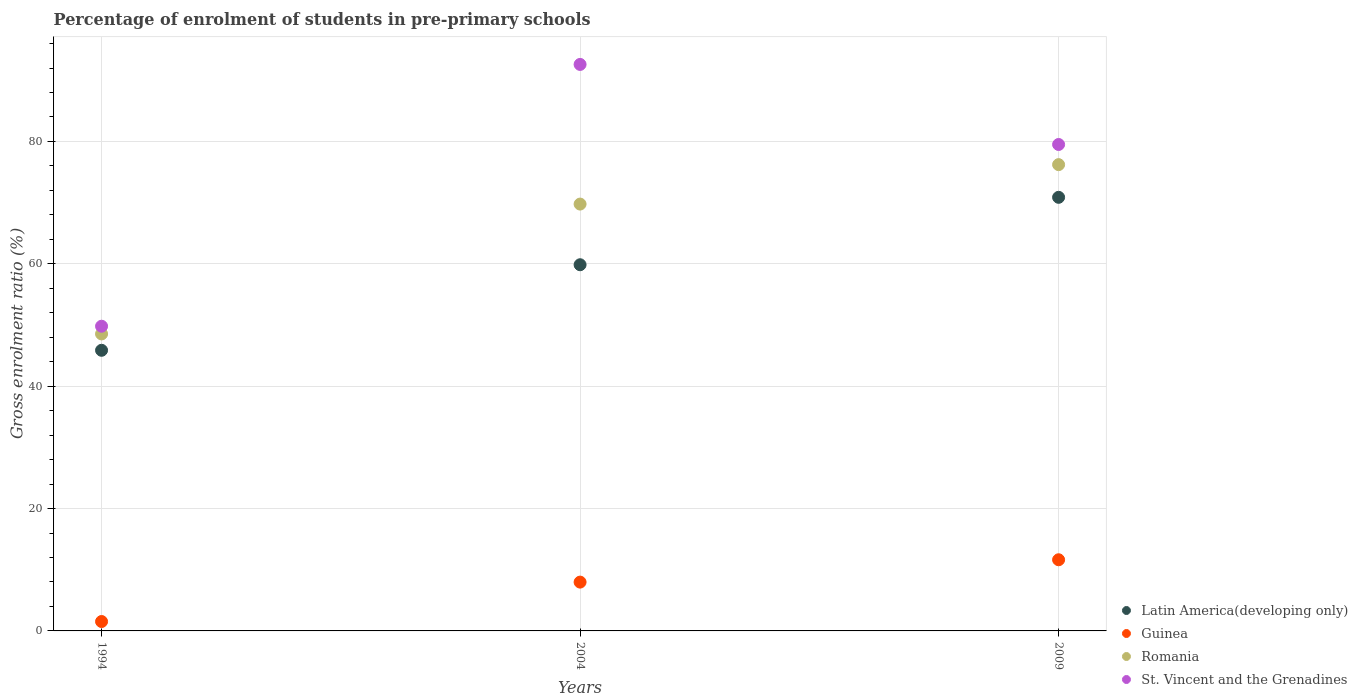How many different coloured dotlines are there?
Your response must be concise. 4. What is the percentage of students enrolled in pre-primary schools in Latin America(developing only) in 2009?
Provide a short and direct response. 70.87. Across all years, what is the maximum percentage of students enrolled in pre-primary schools in Guinea?
Provide a short and direct response. 11.63. Across all years, what is the minimum percentage of students enrolled in pre-primary schools in Latin America(developing only)?
Your answer should be compact. 45.87. In which year was the percentage of students enrolled in pre-primary schools in Guinea maximum?
Make the answer very short. 2009. What is the total percentage of students enrolled in pre-primary schools in Guinea in the graph?
Your answer should be very brief. 21.14. What is the difference between the percentage of students enrolled in pre-primary schools in Latin America(developing only) in 1994 and that in 2009?
Make the answer very short. -25. What is the difference between the percentage of students enrolled in pre-primary schools in Latin America(developing only) in 2004 and the percentage of students enrolled in pre-primary schools in St. Vincent and the Grenadines in 2009?
Offer a terse response. -19.65. What is the average percentage of students enrolled in pre-primary schools in St. Vincent and the Grenadines per year?
Give a very brief answer. 73.97. In the year 2009, what is the difference between the percentage of students enrolled in pre-primary schools in Latin America(developing only) and percentage of students enrolled in pre-primary schools in St. Vincent and the Grenadines?
Offer a terse response. -8.64. In how many years, is the percentage of students enrolled in pre-primary schools in St. Vincent and the Grenadines greater than 52 %?
Ensure brevity in your answer.  2. What is the ratio of the percentage of students enrolled in pre-primary schools in Guinea in 1994 to that in 2009?
Your answer should be very brief. 0.13. Is the difference between the percentage of students enrolled in pre-primary schools in Latin America(developing only) in 2004 and 2009 greater than the difference between the percentage of students enrolled in pre-primary schools in St. Vincent and the Grenadines in 2004 and 2009?
Provide a short and direct response. No. What is the difference between the highest and the second highest percentage of students enrolled in pre-primary schools in Romania?
Offer a very short reply. 6.45. What is the difference between the highest and the lowest percentage of students enrolled in pre-primary schools in Latin America(developing only)?
Your answer should be very brief. 25. In how many years, is the percentage of students enrolled in pre-primary schools in St. Vincent and the Grenadines greater than the average percentage of students enrolled in pre-primary schools in St. Vincent and the Grenadines taken over all years?
Ensure brevity in your answer.  2. Is it the case that in every year, the sum of the percentage of students enrolled in pre-primary schools in Romania and percentage of students enrolled in pre-primary schools in Guinea  is greater than the percentage of students enrolled in pre-primary schools in Latin America(developing only)?
Make the answer very short. Yes. Is the percentage of students enrolled in pre-primary schools in Guinea strictly less than the percentage of students enrolled in pre-primary schools in St. Vincent and the Grenadines over the years?
Ensure brevity in your answer.  Yes. Are the values on the major ticks of Y-axis written in scientific E-notation?
Offer a very short reply. No. Does the graph contain grids?
Make the answer very short. Yes. Where does the legend appear in the graph?
Your response must be concise. Bottom right. How many legend labels are there?
Your response must be concise. 4. What is the title of the graph?
Offer a very short reply. Percentage of enrolment of students in pre-primary schools. Does "Cabo Verde" appear as one of the legend labels in the graph?
Offer a terse response. No. What is the label or title of the Y-axis?
Your answer should be very brief. Gross enrolment ratio (%). What is the Gross enrolment ratio (%) in Latin America(developing only) in 1994?
Ensure brevity in your answer.  45.87. What is the Gross enrolment ratio (%) in Guinea in 1994?
Give a very brief answer. 1.54. What is the Gross enrolment ratio (%) in Romania in 1994?
Your answer should be very brief. 48.54. What is the Gross enrolment ratio (%) in St. Vincent and the Grenadines in 1994?
Your answer should be very brief. 49.8. What is the Gross enrolment ratio (%) of Latin America(developing only) in 2004?
Provide a short and direct response. 59.85. What is the Gross enrolment ratio (%) of Guinea in 2004?
Your response must be concise. 7.98. What is the Gross enrolment ratio (%) in Romania in 2004?
Ensure brevity in your answer.  69.77. What is the Gross enrolment ratio (%) in St. Vincent and the Grenadines in 2004?
Give a very brief answer. 92.59. What is the Gross enrolment ratio (%) in Latin America(developing only) in 2009?
Make the answer very short. 70.87. What is the Gross enrolment ratio (%) of Guinea in 2009?
Provide a short and direct response. 11.63. What is the Gross enrolment ratio (%) of Romania in 2009?
Offer a very short reply. 76.21. What is the Gross enrolment ratio (%) of St. Vincent and the Grenadines in 2009?
Your answer should be very brief. 79.51. Across all years, what is the maximum Gross enrolment ratio (%) of Latin America(developing only)?
Offer a terse response. 70.87. Across all years, what is the maximum Gross enrolment ratio (%) in Guinea?
Provide a succinct answer. 11.63. Across all years, what is the maximum Gross enrolment ratio (%) in Romania?
Offer a very short reply. 76.21. Across all years, what is the maximum Gross enrolment ratio (%) in St. Vincent and the Grenadines?
Keep it short and to the point. 92.59. Across all years, what is the minimum Gross enrolment ratio (%) of Latin America(developing only)?
Offer a terse response. 45.87. Across all years, what is the minimum Gross enrolment ratio (%) in Guinea?
Provide a succinct answer. 1.54. Across all years, what is the minimum Gross enrolment ratio (%) in Romania?
Give a very brief answer. 48.54. Across all years, what is the minimum Gross enrolment ratio (%) of St. Vincent and the Grenadines?
Offer a terse response. 49.8. What is the total Gross enrolment ratio (%) in Latin America(developing only) in the graph?
Make the answer very short. 176.59. What is the total Gross enrolment ratio (%) in Guinea in the graph?
Provide a succinct answer. 21.14. What is the total Gross enrolment ratio (%) in Romania in the graph?
Your response must be concise. 194.52. What is the total Gross enrolment ratio (%) of St. Vincent and the Grenadines in the graph?
Provide a succinct answer. 221.9. What is the difference between the Gross enrolment ratio (%) of Latin America(developing only) in 1994 and that in 2004?
Your answer should be compact. -13.98. What is the difference between the Gross enrolment ratio (%) of Guinea in 1994 and that in 2004?
Provide a succinct answer. -6.44. What is the difference between the Gross enrolment ratio (%) in Romania in 1994 and that in 2004?
Ensure brevity in your answer.  -21.22. What is the difference between the Gross enrolment ratio (%) in St. Vincent and the Grenadines in 1994 and that in 2004?
Your answer should be compact. -42.79. What is the difference between the Gross enrolment ratio (%) of Latin America(developing only) in 1994 and that in 2009?
Give a very brief answer. -25. What is the difference between the Gross enrolment ratio (%) of Guinea in 1994 and that in 2009?
Offer a terse response. -10.09. What is the difference between the Gross enrolment ratio (%) in Romania in 1994 and that in 2009?
Your answer should be very brief. -27.67. What is the difference between the Gross enrolment ratio (%) in St. Vincent and the Grenadines in 1994 and that in 2009?
Your answer should be compact. -29.7. What is the difference between the Gross enrolment ratio (%) in Latin America(developing only) in 2004 and that in 2009?
Provide a succinct answer. -11.02. What is the difference between the Gross enrolment ratio (%) in Guinea in 2004 and that in 2009?
Your answer should be compact. -3.65. What is the difference between the Gross enrolment ratio (%) in Romania in 2004 and that in 2009?
Provide a succinct answer. -6.45. What is the difference between the Gross enrolment ratio (%) of St. Vincent and the Grenadines in 2004 and that in 2009?
Your response must be concise. 13.08. What is the difference between the Gross enrolment ratio (%) of Latin America(developing only) in 1994 and the Gross enrolment ratio (%) of Guinea in 2004?
Offer a very short reply. 37.89. What is the difference between the Gross enrolment ratio (%) in Latin America(developing only) in 1994 and the Gross enrolment ratio (%) in Romania in 2004?
Offer a very short reply. -23.9. What is the difference between the Gross enrolment ratio (%) in Latin America(developing only) in 1994 and the Gross enrolment ratio (%) in St. Vincent and the Grenadines in 2004?
Your answer should be compact. -46.72. What is the difference between the Gross enrolment ratio (%) in Guinea in 1994 and the Gross enrolment ratio (%) in Romania in 2004?
Give a very brief answer. -68.23. What is the difference between the Gross enrolment ratio (%) in Guinea in 1994 and the Gross enrolment ratio (%) in St. Vincent and the Grenadines in 2004?
Provide a succinct answer. -91.05. What is the difference between the Gross enrolment ratio (%) of Romania in 1994 and the Gross enrolment ratio (%) of St. Vincent and the Grenadines in 2004?
Provide a short and direct response. -44.05. What is the difference between the Gross enrolment ratio (%) in Latin America(developing only) in 1994 and the Gross enrolment ratio (%) in Guinea in 2009?
Provide a short and direct response. 34.24. What is the difference between the Gross enrolment ratio (%) in Latin America(developing only) in 1994 and the Gross enrolment ratio (%) in Romania in 2009?
Your answer should be compact. -30.35. What is the difference between the Gross enrolment ratio (%) in Latin America(developing only) in 1994 and the Gross enrolment ratio (%) in St. Vincent and the Grenadines in 2009?
Provide a short and direct response. -33.64. What is the difference between the Gross enrolment ratio (%) in Guinea in 1994 and the Gross enrolment ratio (%) in Romania in 2009?
Provide a succinct answer. -74.68. What is the difference between the Gross enrolment ratio (%) in Guinea in 1994 and the Gross enrolment ratio (%) in St. Vincent and the Grenadines in 2009?
Give a very brief answer. -77.97. What is the difference between the Gross enrolment ratio (%) of Romania in 1994 and the Gross enrolment ratio (%) of St. Vincent and the Grenadines in 2009?
Ensure brevity in your answer.  -30.96. What is the difference between the Gross enrolment ratio (%) of Latin America(developing only) in 2004 and the Gross enrolment ratio (%) of Guinea in 2009?
Make the answer very short. 48.22. What is the difference between the Gross enrolment ratio (%) of Latin America(developing only) in 2004 and the Gross enrolment ratio (%) of Romania in 2009?
Your answer should be very brief. -16.36. What is the difference between the Gross enrolment ratio (%) in Latin America(developing only) in 2004 and the Gross enrolment ratio (%) in St. Vincent and the Grenadines in 2009?
Make the answer very short. -19.65. What is the difference between the Gross enrolment ratio (%) of Guinea in 2004 and the Gross enrolment ratio (%) of Romania in 2009?
Offer a terse response. -68.23. What is the difference between the Gross enrolment ratio (%) of Guinea in 2004 and the Gross enrolment ratio (%) of St. Vincent and the Grenadines in 2009?
Offer a terse response. -71.53. What is the difference between the Gross enrolment ratio (%) of Romania in 2004 and the Gross enrolment ratio (%) of St. Vincent and the Grenadines in 2009?
Ensure brevity in your answer.  -9.74. What is the average Gross enrolment ratio (%) in Latin America(developing only) per year?
Provide a short and direct response. 58.86. What is the average Gross enrolment ratio (%) in Guinea per year?
Offer a very short reply. 7.05. What is the average Gross enrolment ratio (%) of Romania per year?
Keep it short and to the point. 64.84. What is the average Gross enrolment ratio (%) in St. Vincent and the Grenadines per year?
Your response must be concise. 73.97. In the year 1994, what is the difference between the Gross enrolment ratio (%) in Latin America(developing only) and Gross enrolment ratio (%) in Guinea?
Ensure brevity in your answer.  44.33. In the year 1994, what is the difference between the Gross enrolment ratio (%) in Latin America(developing only) and Gross enrolment ratio (%) in Romania?
Ensure brevity in your answer.  -2.67. In the year 1994, what is the difference between the Gross enrolment ratio (%) in Latin America(developing only) and Gross enrolment ratio (%) in St. Vincent and the Grenadines?
Your answer should be compact. -3.93. In the year 1994, what is the difference between the Gross enrolment ratio (%) of Guinea and Gross enrolment ratio (%) of Romania?
Offer a very short reply. -47.01. In the year 1994, what is the difference between the Gross enrolment ratio (%) of Guinea and Gross enrolment ratio (%) of St. Vincent and the Grenadines?
Keep it short and to the point. -48.27. In the year 1994, what is the difference between the Gross enrolment ratio (%) in Romania and Gross enrolment ratio (%) in St. Vincent and the Grenadines?
Your answer should be very brief. -1.26. In the year 2004, what is the difference between the Gross enrolment ratio (%) of Latin America(developing only) and Gross enrolment ratio (%) of Guinea?
Your answer should be very brief. 51.87. In the year 2004, what is the difference between the Gross enrolment ratio (%) in Latin America(developing only) and Gross enrolment ratio (%) in Romania?
Your answer should be compact. -9.91. In the year 2004, what is the difference between the Gross enrolment ratio (%) in Latin America(developing only) and Gross enrolment ratio (%) in St. Vincent and the Grenadines?
Provide a succinct answer. -32.74. In the year 2004, what is the difference between the Gross enrolment ratio (%) in Guinea and Gross enrolment ratio (%) in Romania?
Ensure brevity in your answer.  -61.79. In the year 2004, what is the difference between the Gross enrolment ratio (%) in Guinea and Gross enrolment ratio (%) in St. Vincent and the Grenadines?
Offer a very short reply. -84.61. In the year 2004, what is the difference between the Gross enrolment ratio (%) in Romania and Gross enrolment ratio (%) in St. Vincent and the Grenadines?
Offer a very short reply. -22.82. In the year 2009, what is the difference between the Gross enrolment ratio (%) in Latin America(developing only) and Gross enrolment ratio (%) in Guinea?
Your answer should be compact. 59.24. In the year 2009, what is the difference between the Gross enrolment ratio (%) in Latin America(developing only) and Gross enrolment ratio (%) in Romania?
Your answer should be compact. -5.34. In the year 2009, what is the difference between the Gross enrolment ratio (%) in Latin America(developing only) and Gross enrolment ratio (%) in St. Vincent and the Grenadines?
Keep it short and to the point. -8.64. In the year 2009, what is the difference between the Gross enrolment ratio (%) in Guinea and Gross enrolment ratio (%) in Romania?
Offer a very short reply. -64.58. In the year 2009, what is the difference between the Gross enrolment ratio (%) in Guinea and Gross enrolment ratio (%) in St. Vincent and the Grenadines?
Make the answer very short. -67.87. In the year 2009, what is the difference between the Gross enrolment ratio (%) of Romania and Gross enrolment ratio (%) of St. Vincent and the Grenadines?
Ensure brevity in your answer.  -3.29. What is the ratio of the Gross enrolment ratio (%) in Latin America(developing only) in 1994 to that in 2004?
Offer a terse response. 0.77. What is the ratio of the Gross enrolment ratio (%) in Guinea in 1994 to that in 2004?
Give a very brief answer. 0.19. What is the ratio of the Gross enrolment ratio (%) in Romania in 1994 to that in 2004?
Your answer should be compact. 0.7. What is the ratio of the Gross enrolment ratio (%) of St. Vincent and the Grenadines in 1994 to that in 2004?
Keep it short and to the point. 0.54. What is the ratio of the Gross enrolment ratio (%) in Latin America(developing only) in 1994 to that in 2009?
Provide a succinct answer. 0.65. What is the ratio of the Gross enrolment ratio (%) of Guinea in 1994 to that in 2009?
Offer a terse response. 0.13. What is the ratio of the Gross enrolment ratio (%) of Romania in 1994 to that in 2009?
Offer a terse response. 0.64. What is the ratio of the Gross enrolment ratio (%) of St. Vincent and the Grenadines in 1994 to that in 2009?
Ensure brevity in your answer.  0.63. What is the ratio of the Gross enrolment ratio (%) in Latin America(developing only) in 2004 to that in 2009?
Ensure brevity in your answer.  0.84. What is the ratio of the Gross enrolment ratio (%) of Guinea in 2004 to that in 2009?
Your response must be concise. 0.69. What is the ratio of the Gross enrolment ratio (%) in Romania in 2004 to that in 2009?
Give a very brief answer. 0.92. What is the ratio of the Gross enrolment ratio (%) in St. Vincent and the Grenadines in 2004 to that in 2009?
Your answer should be compact. 1.16. What is the difference between the highest and the second highest Gross enrolment ratio (%) of Latin America(developing only)?
Provide a succinct answer. 11.02. What is the difference between the highest and the second highest Gross enrolment ratio (%) in Guinea?
Your answer should be very brief. 3.65. What is the difference between the highest and the second highest Gross enrolment ratio (%) in Romania?
Provide a succinct answer. 6.45. What is the difference between the highest and the second highest Gross enrolment ratio (%) in St. Vincent and the Grenadines?
Offer a very short reply. 13.08. What is the difference between the highest and the lowest Gross enrolment ratio (%) of Latin America(developing only)?
Provide a short and direct response. 25. What is the difference between the highest and the lowest Gross enrolment ratio (%) of Guinea?
Your answer should be very brief. 10.09. What is the difference between the highest and the lowest Gross enrolment ratio (%) of Romania?
Provide a succinct answer. 27.67. What is the difference between the highest and the lowest Gross enrolment ratio (%) of St. Vincent and the Grenadines?
Your response must be concise. 42.79. 